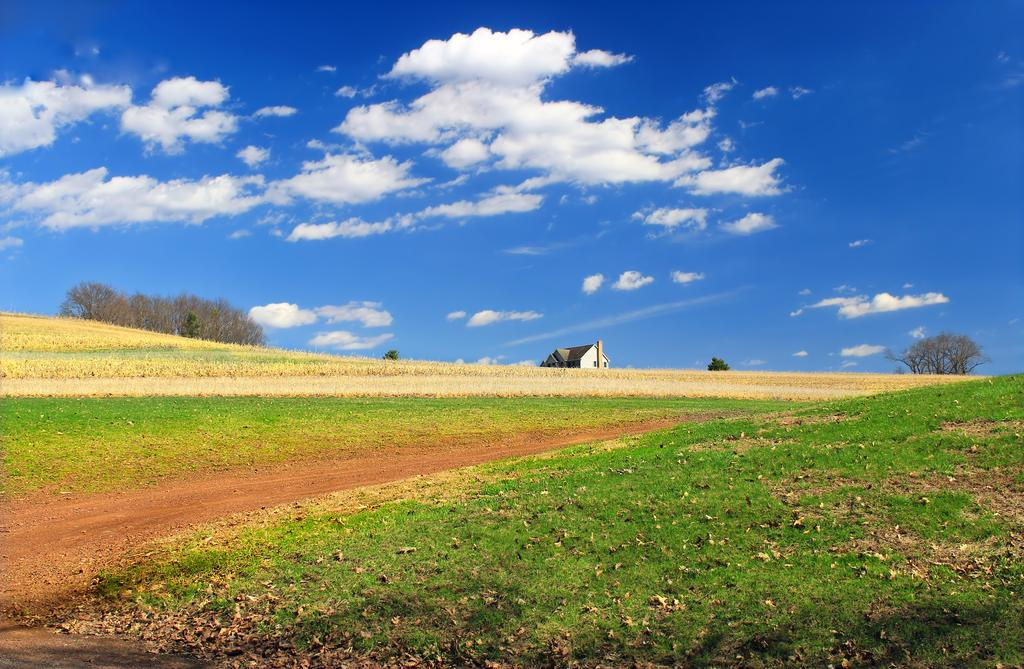What type of surface is visible in the image? There is grass on the surface of the area. What is the main structure located in the image? There is a house at the center of the image. What can be seen in the background of the image? There is a sky visible in the background of the image. Can you see any evidence of a fight between a robin and a squirrel in the image? There is no evidence of a fight between a robin and a squirrel in the image, as neither animal is present. 